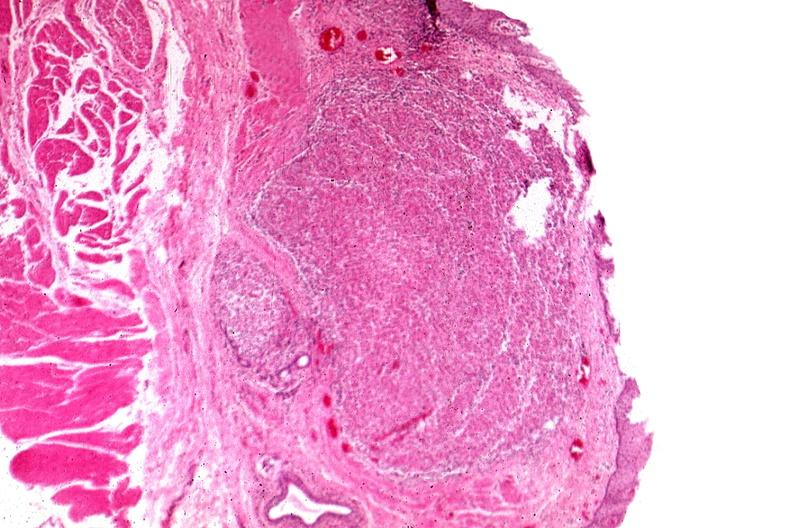s papillary intraductal adenocarcinoma present?
Answer the question using a single word or phrase. No 